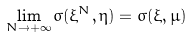<formula> <loc_0><loc_0><loc_500><loc_500>\lim _ { N \rightarrow + \infty } \sigma ( \xi ^ { N } , \eta ) = \sigma ( \xi , \mu )</formula> 